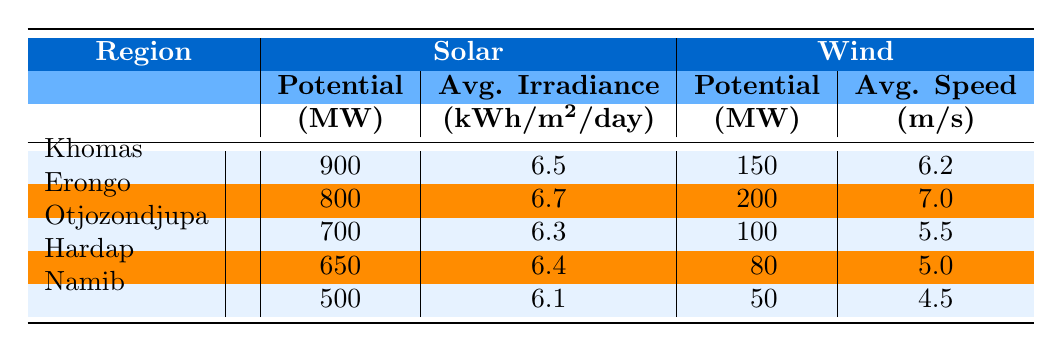What is the solar potential in the Khomas region? The solar potential for Khomas is given in the table under the Solar section, which states the Potential as 900 MW.
Answer: 900 MW Which region has the highest average solar irradiance? From the table, we compare the Average Solar Irradiance values across all regions. Erongo has the highest value at 6.7 kWh/m2/day.
Answer: Erongo What is the total wind potential for the regions of Otjozondjupa and Namib? To find the total wind potential for Otjozondjupa and Namib, we add their Potential MW values: Otjozondjupa has 100 MW and Namib has 50 MW, so the total is 100 + 50 = 150 MW.
Answer: 150 MW Is the average wind speed higher in Erongo than in Khomas? The Average Wind Speed for Erongo is 7.0 m/s and for Khomas it is 6.2 m/s. Since 7.0 is greater than 6.2, the statement is true.
Answer: Yes Which region has a solar potential below 700 MW? By analyzing the table, we see that both Hardap (650 MW) and Namib (500 MW) have solar potentials below 700 MW.
Answer: Hardap and Namib What is the average potential of solar energy across all regions? To find the average solar potential, we sum the solar potentials for all regions (900 + 800 + 700 + 650 + 500 = 3550) and divide by the number of regions (5). The average is 3550 / 5 = 710 MW.
Answer: 710 MW Is the average solar irradiance in Hardap higher or lower than that of Otjozondjupa? The table shows that Hardap has an Average Solar Irradiance of 6.4 kWh/m2/day while Otjozondjupa has 6.3 kWh/m2/day. Since 6.4 is greater than 6.3, the average is higher in Hardap.
Answer: Higher in Hardap What is the difference between the wind potential of Khomas and the wind potential of Erongo? The wind potential for Khomas is 150 MW and for Erongo is 200 MW. The difference is calculated as 200 - 150 = 50 MW.
Answer: 50 MW 